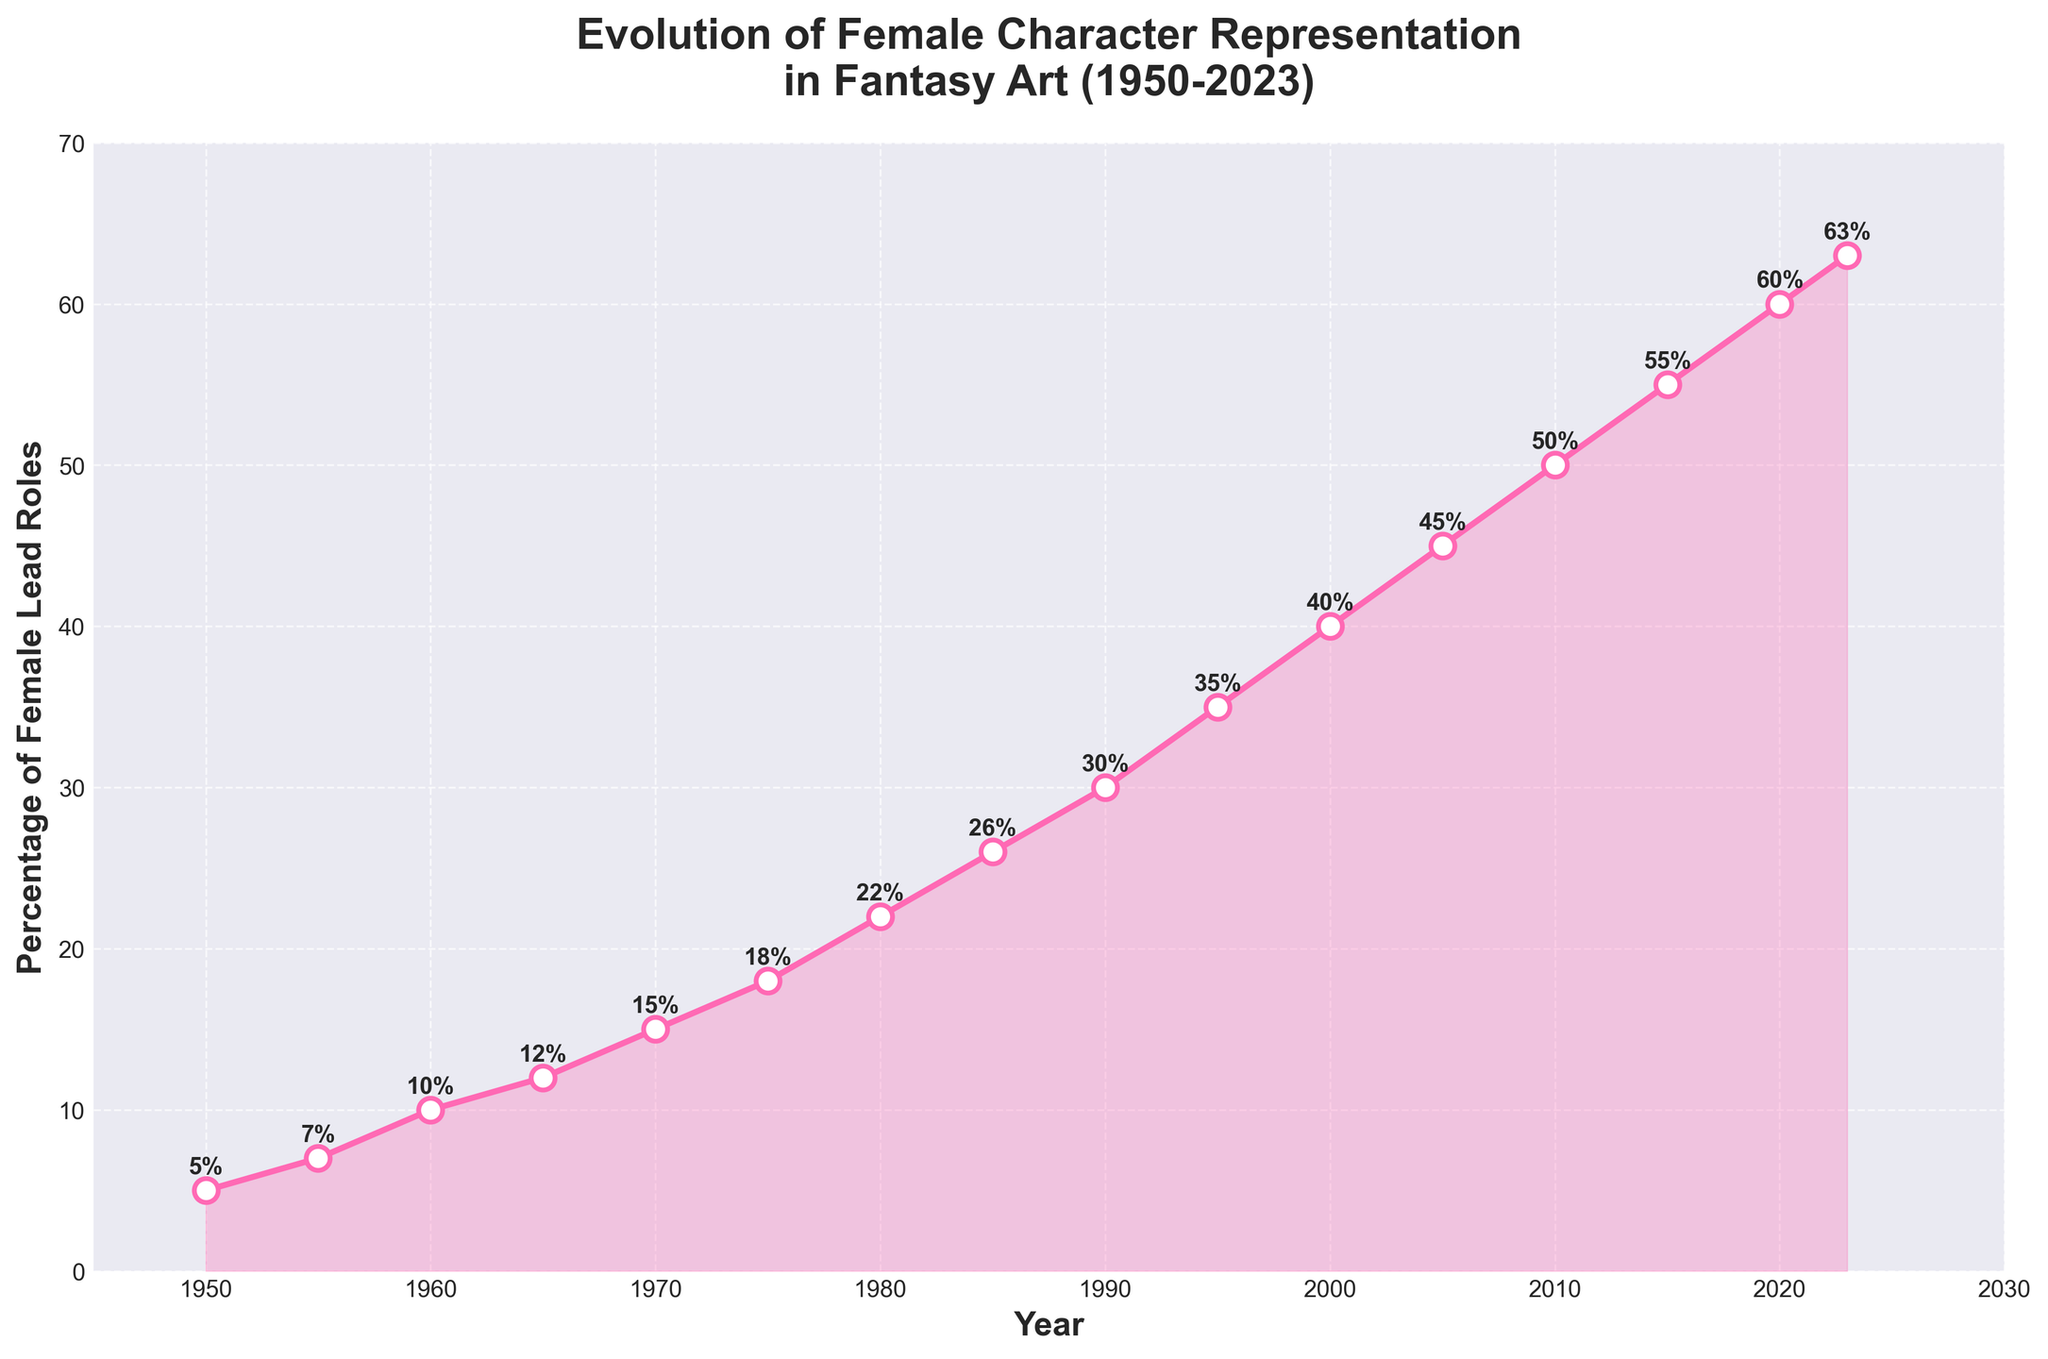What's the percentage of female lead roles in fantasy art in 2020? The plot shows data points marked with "2020" on the x-axis. The y-axis corresponding to 2020 indicates 60%.
Answer: 60% Between which years did the percentage of female lead roles increase the most? By observing the steepness of the line segment between data points, we see that the steepest incline is between 2005 and 2010.
Answer: 2005 and 2010 By how much did the percentage of female lead roles increase from 1950 to 1990? The percentage in 1950 is 5%, and in 1990 it is 30%. The increase is 30% - 5% = 25%.
Answer: 25% Between 1950 and 2023, what is the average percentage increase per decade? We need to find the total increase over the years and then divide by the number of decades. Total increase from 1950 (5%) to 2023 (63%) is 63% - 5% = 58%. There are approximately 7.3 decades between 1950 and 2023 (73 years). So, the increase per decade is 58% / 7.3 ≈ 7.95%.
Answer: ~7.95% In which decade did the percentage of female lead roles in fantasy art first exceed 30%? Looking at the plot, the percentage exceeded 30% between the years 1990 (30%) and 1995 (35%), which is within the decade of the 1990s.
Answer: 1990s What trend do you observe from 1950 to 2023 in terms of female lead representation in fantasy art? The trend shows a steady increase in the percentage of female lead roles, with the line sloping upward consistently from 1950 to 2023.
Answer: Steady increase Compare the increase in percentage of female lead roles between the 1950s (1950-1960) and the 2000s (2000-2010). Which decade saw a more significant increase? The increase from 1950 to 1960 is 10% - 5% = 5%. The increase from 2000 to 2010 is 50% - 40% = 10%. The 2000s saw a more significant increase.
Answer: 2000s What is the difference in the percentage of female lead roles between 1970 and 1985? In 1970, the percentage is 15%, and in 1985 it is 26%. The difference is 26% - 15% = 11%.
Answer: 11% At what year does the graph show 50% female lead roles in fantasy art? The line chart shows a 50% mark at the year 2010.
Answer: 2010 How has the visual representation of the plot (e.g., color, markers) been used to highlight the trend in female lead roles? The line is depicted with a vibrant pink color, and markers are used with white centers and pink edges to emphasize data points. The fill between the line and the x-axis also subtly highlights the increasing trend from 1950 to 2023.
Answer: Use of vibrant pink color and markers 